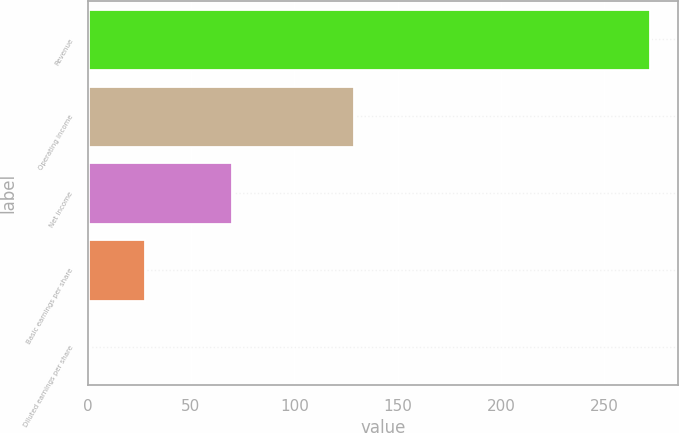<chart> <loc_0><loc_0><loc_500><loc_500><bar_chart><fcel>Revenue<fcel>Operating income<fcel>Net income<fcel>Basic earnings per share<fcel>Diluted earnings per share<nl><fcel>271.9<fcel>129<fcel>69.8<fcel>27.59<fcel>0.45<nl></chart> 